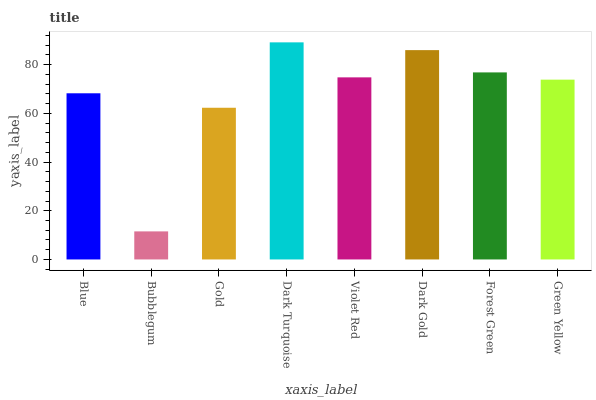Is Bubblegum the minimum?
Answer yes or no. Yes. Is Dark Turquoise the maximum?
Answer yes or no. Yes. Is Gold the minimum?
Answer yes or no. No. Is Gold the maximum?
Answer yes or no. No. Is Gold greater than Bubblegum?
Answer yes or no. Yes. Is Bubblegum less than Gold?
Answer yes or no. Yes. Is Bubblegum greater than Gold?
Answer yes or no. No. Is Gold less than Bubblegum?
Answer yes or no. No. Is Violet Red the high median?
Answer yes or no. Yes. Is Green Yellow the low median?
Answer yes or no. Yes. Is Green Yellow the high median?
Answer yes or no. No. Is Violet Red the low median?
Answer yes or no. No. 